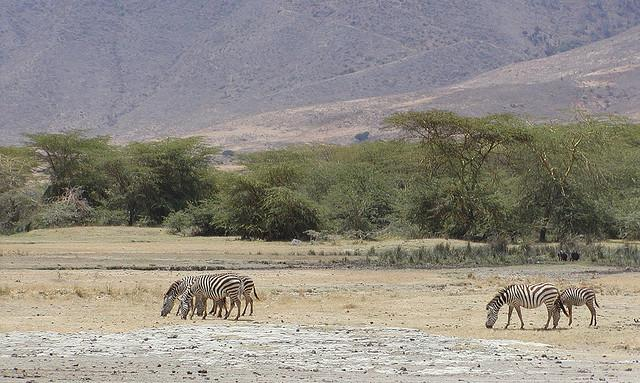What continent do these animals naturally live on? Please explain your reasoning. australia. These would be quite common in the savannah as evidenced by the dry, desert-like ground they are on. 